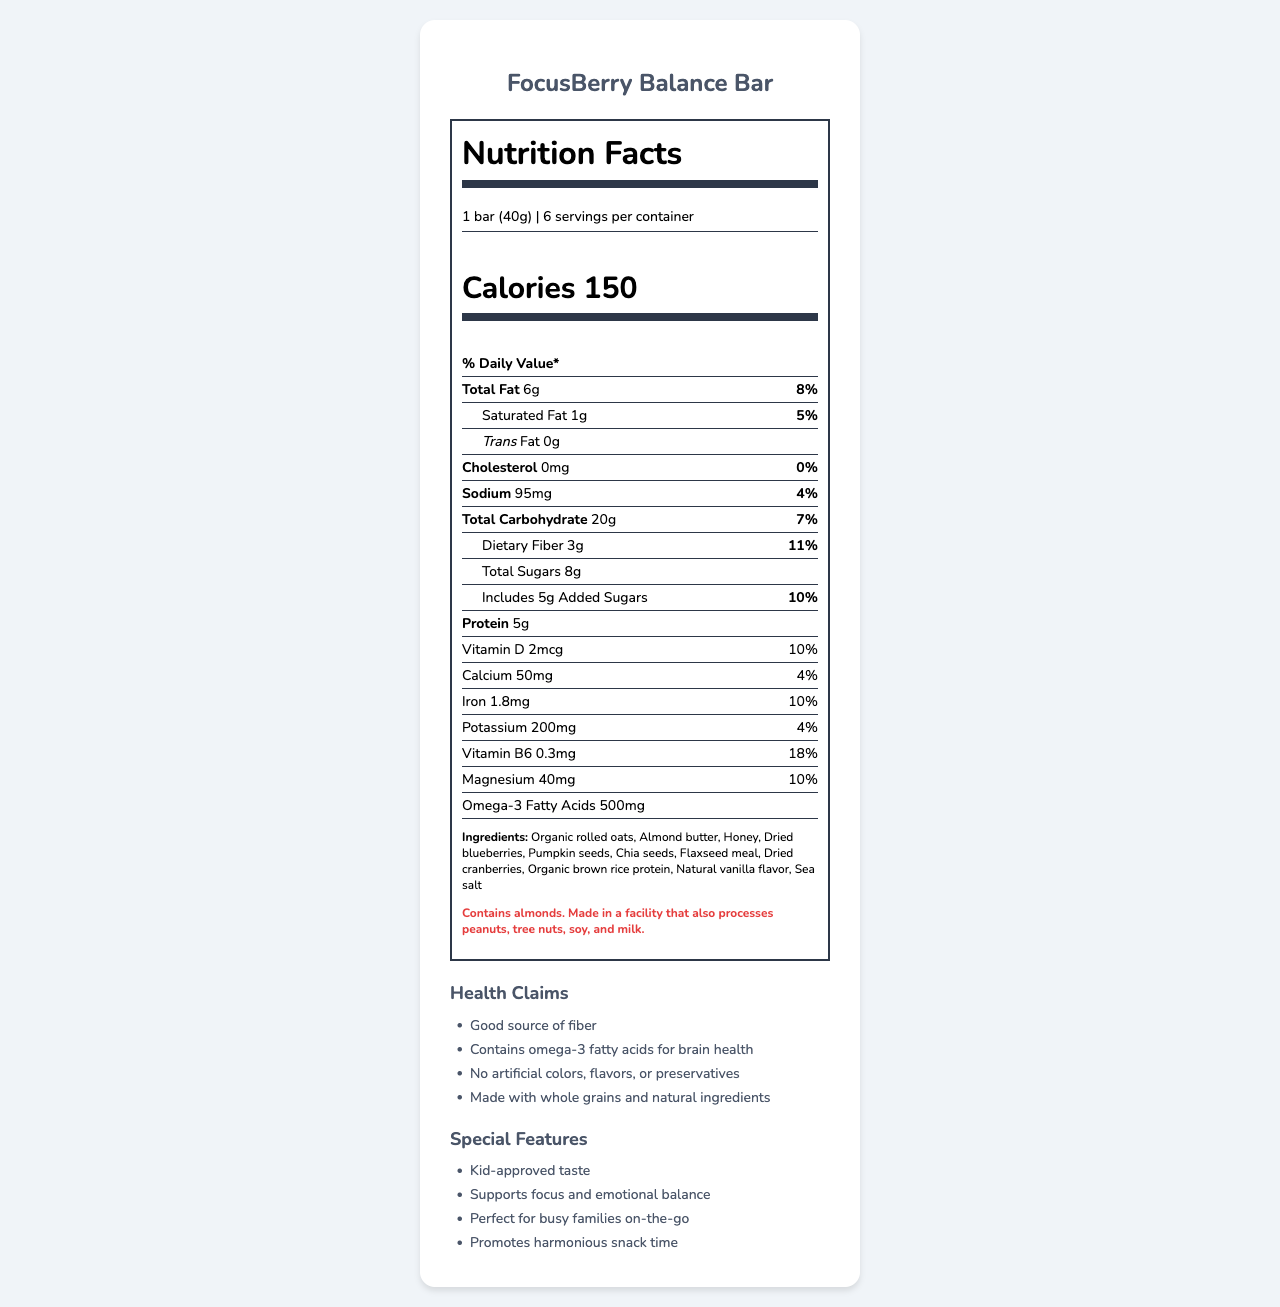what is the serving size for the FocusBerry Balance Bar? The serving size is clearly stated as "1 bar (40g)" in the nutrition facts.
Answer: 1 bar (40g) how many calories are in one serving of the FocusBerry Balance Bar? The calories per serving are listed as 150 in the nutrition facts.
Answer: 150 what is the total fat content in one serving? The total fat content per serving is indicated as 6g.
Answer: 6g what are the main ingredients in the FocusBerry Balance Bar? The main ingredients are listed in the ingredients section.
Answer: Organic rolled oats, Almond butter, Honey, Dried blueberries, Pumpkin seeds, Chia seeds, Flaxseed meal, Dried cranberries, Organic brown rice protein, Natural vanilla flavor, Sea salt how much protein does one bar provide? The protein content per serving is listed as 5g.
Answer: 5g how many daily values of Vitamin B6 does the bar contain? The daily value percentage for Vitamin B6 is indicated as 18%.
Answer: 18% what allergens are mentioned for the FocusBerry Balance Bar? The allergen information clearly states the allergens and potential cross-contaminants.
Answer: Contains almonds. Made in a facility that also processes peanuts, tree nuts, soy, and milk. which vitamin in the bar is present at 10% daily value? A. Vitamin D B. Vitamin B6 C. Magnesium D. Potassium The document states that Vitamin D is present at 10% daily value.
Answer: A. Vitamin D which feature is NOT included in the health claims? A. Good source of fiber B. Made with whole grains and natural ingredients C. Low calorie A "Low calorie" claim isn't listed among the health claims provided.
Answer: C. Low calorie does the FocusBerry Balance Bar contain any trans fat? The nutrition label indicates that trans fat content is 0g.
Answer: No can the document tell us the manufacturing date of the FocusBerry Balance Bar? There isn't any information provided about the manufacturing date.
Answer: Not enough information does the bar help in promoting emotional balance according to the document? The document lists "Supports focus and emotional balance" as one of its special features.
Answer: Yes how much dietary fiber is in one serving of the bar? Dietary fiber per serving is listed as 3g.
Answer: 3g how many servings are there per container? The servings per container are stated as 6.
Answer: 6 summarize the key features and nutrition facts provided in the document. The explanation gives a comprehensive description of the bar's nutritional values, ingredients, health claims, special features, and any allergen risks.
Answer: The FocusBerry Balance Bar is described as a kid-approved snack aimed at promoting focus and emotional balance. It has 150 calories per serving with 6g of total fat, 1g of saturated fat, and no trans fat. It provides 5g of protein and contains 3g of dietary fiber and 8g of total sugars including 5g of added sugars. The bar includes various vitamins and minerals such as Vitamin D (10% DV), iron (10% DV), and Vitamin B6 (18% DV). The bar contains several natural ingredients and allergens such as almonds. No artificial colors, flavors, or preservatives are used, and it is made with whole grains. The bar promotes harmonious snack time for busy families. 